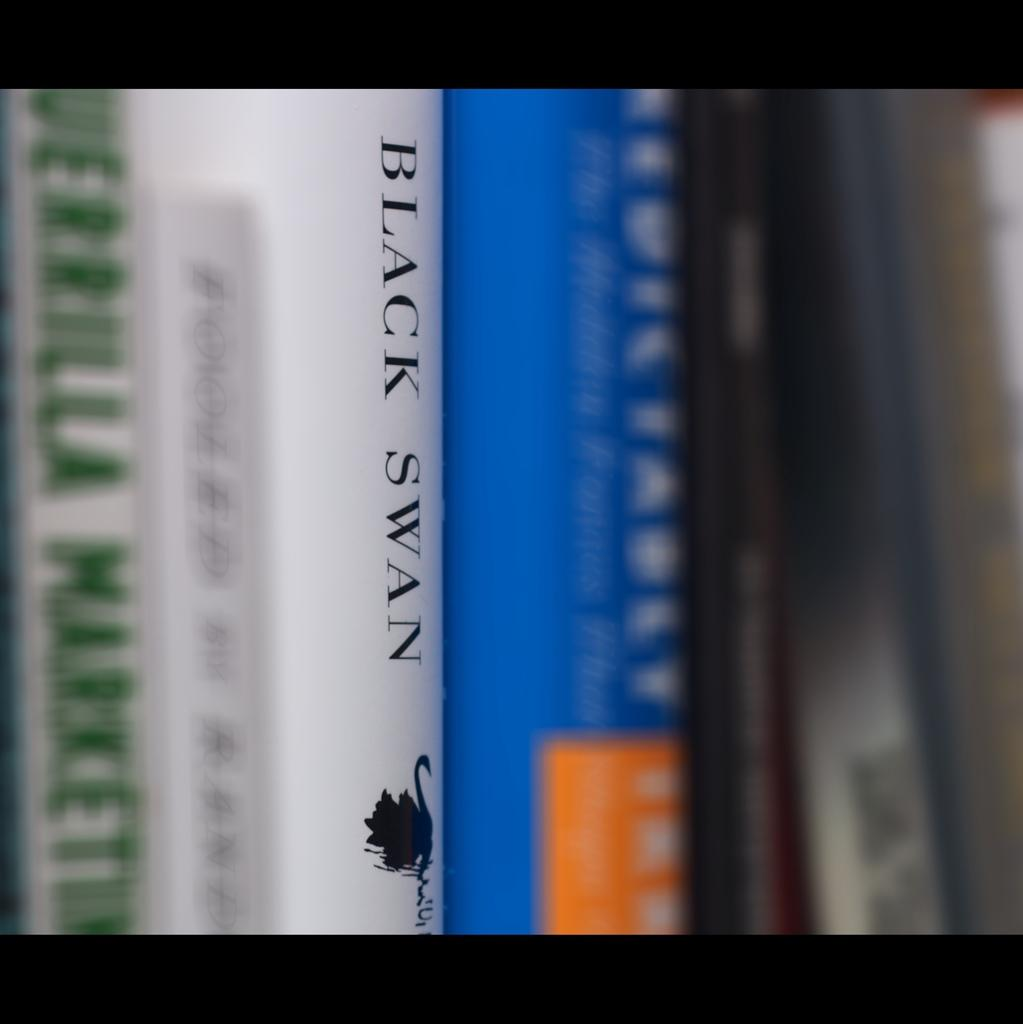<image>
Create a compact narrative representing the image presented. Several books side by side and Black Swan with white book jacket in the middle 